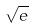Convert formula to latex. <formula><loc_0><loc_0><loc_500><loc_500>\sqrt { e }</formula> 